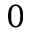Convert formula to latex. <formula><loc_0><loc_0><loc_500><loc_500>0</formula> 